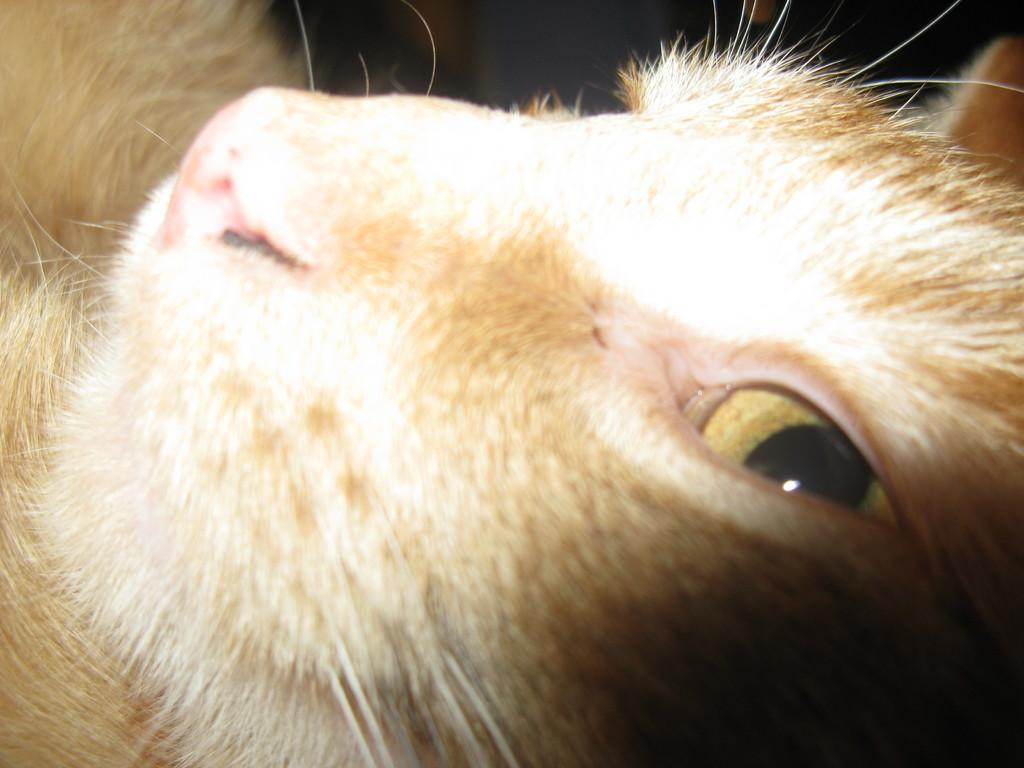What type of animal is in the image? There is a cat in the image. What part of the cat can be seen in the image? The cat's eye is visible in the image. What type of wool is the cat wearing on its paw in the image? There is no wool or clothing visible on the cat in the image. 